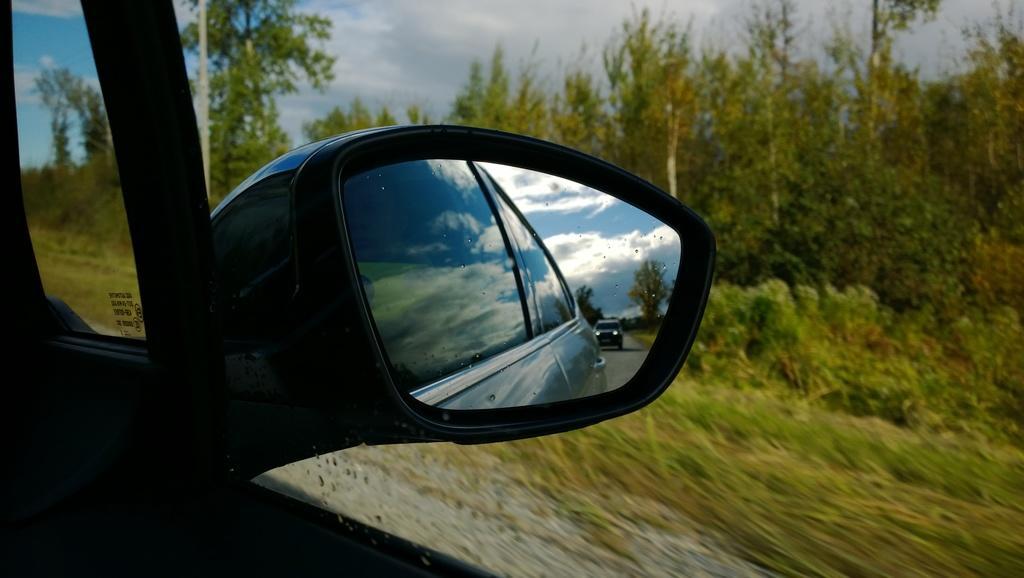How would you summarize this image in a sentence or two? It is a zoomed in picture and in this image we can see the vehicle's mirror and in the mirror we can see the sky, trees and also the car on the road. Image also consists of trees. There is sky with the clouds. 